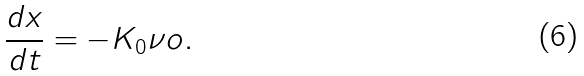Convert formula to latex. <formula><loc_0><loc_0><loc_500><loc_500>\frac { d x } { d t } = - K _ { 0 } \nu o .</formula> 